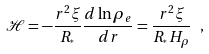<formula> <loc_0><loc_0><loc_500><loc_500>\mathcal { H } = - \frac { r ^ { 2 } \xi } { R _ { ^ { * } } } \frac { d \ln \rho _ { e } } { d r } = \frac { r ^ { 2 } \xi } { R _ { ^ { * } } H _ { \rho } } \ ,</formula> 